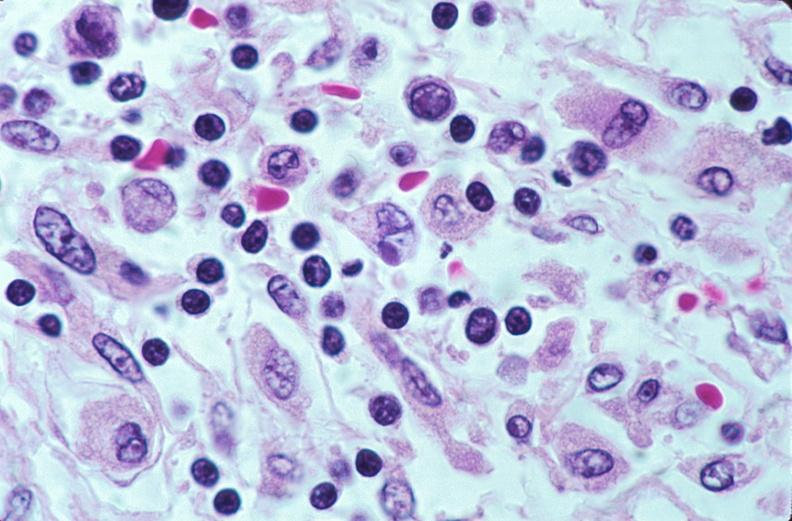does pituitectomy show lymph nodes, nodular sclerosing hodgkins disease?
Answer the question using a single word or phrase. No 